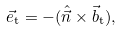<formula> <loc_0><loc_0><loc_500><loc_500>\vec { e } _ { \mathrm t } = - ( \hat { \vec { n } } \times \vec { b } _ { \mathrm t } ) ,</formula> 